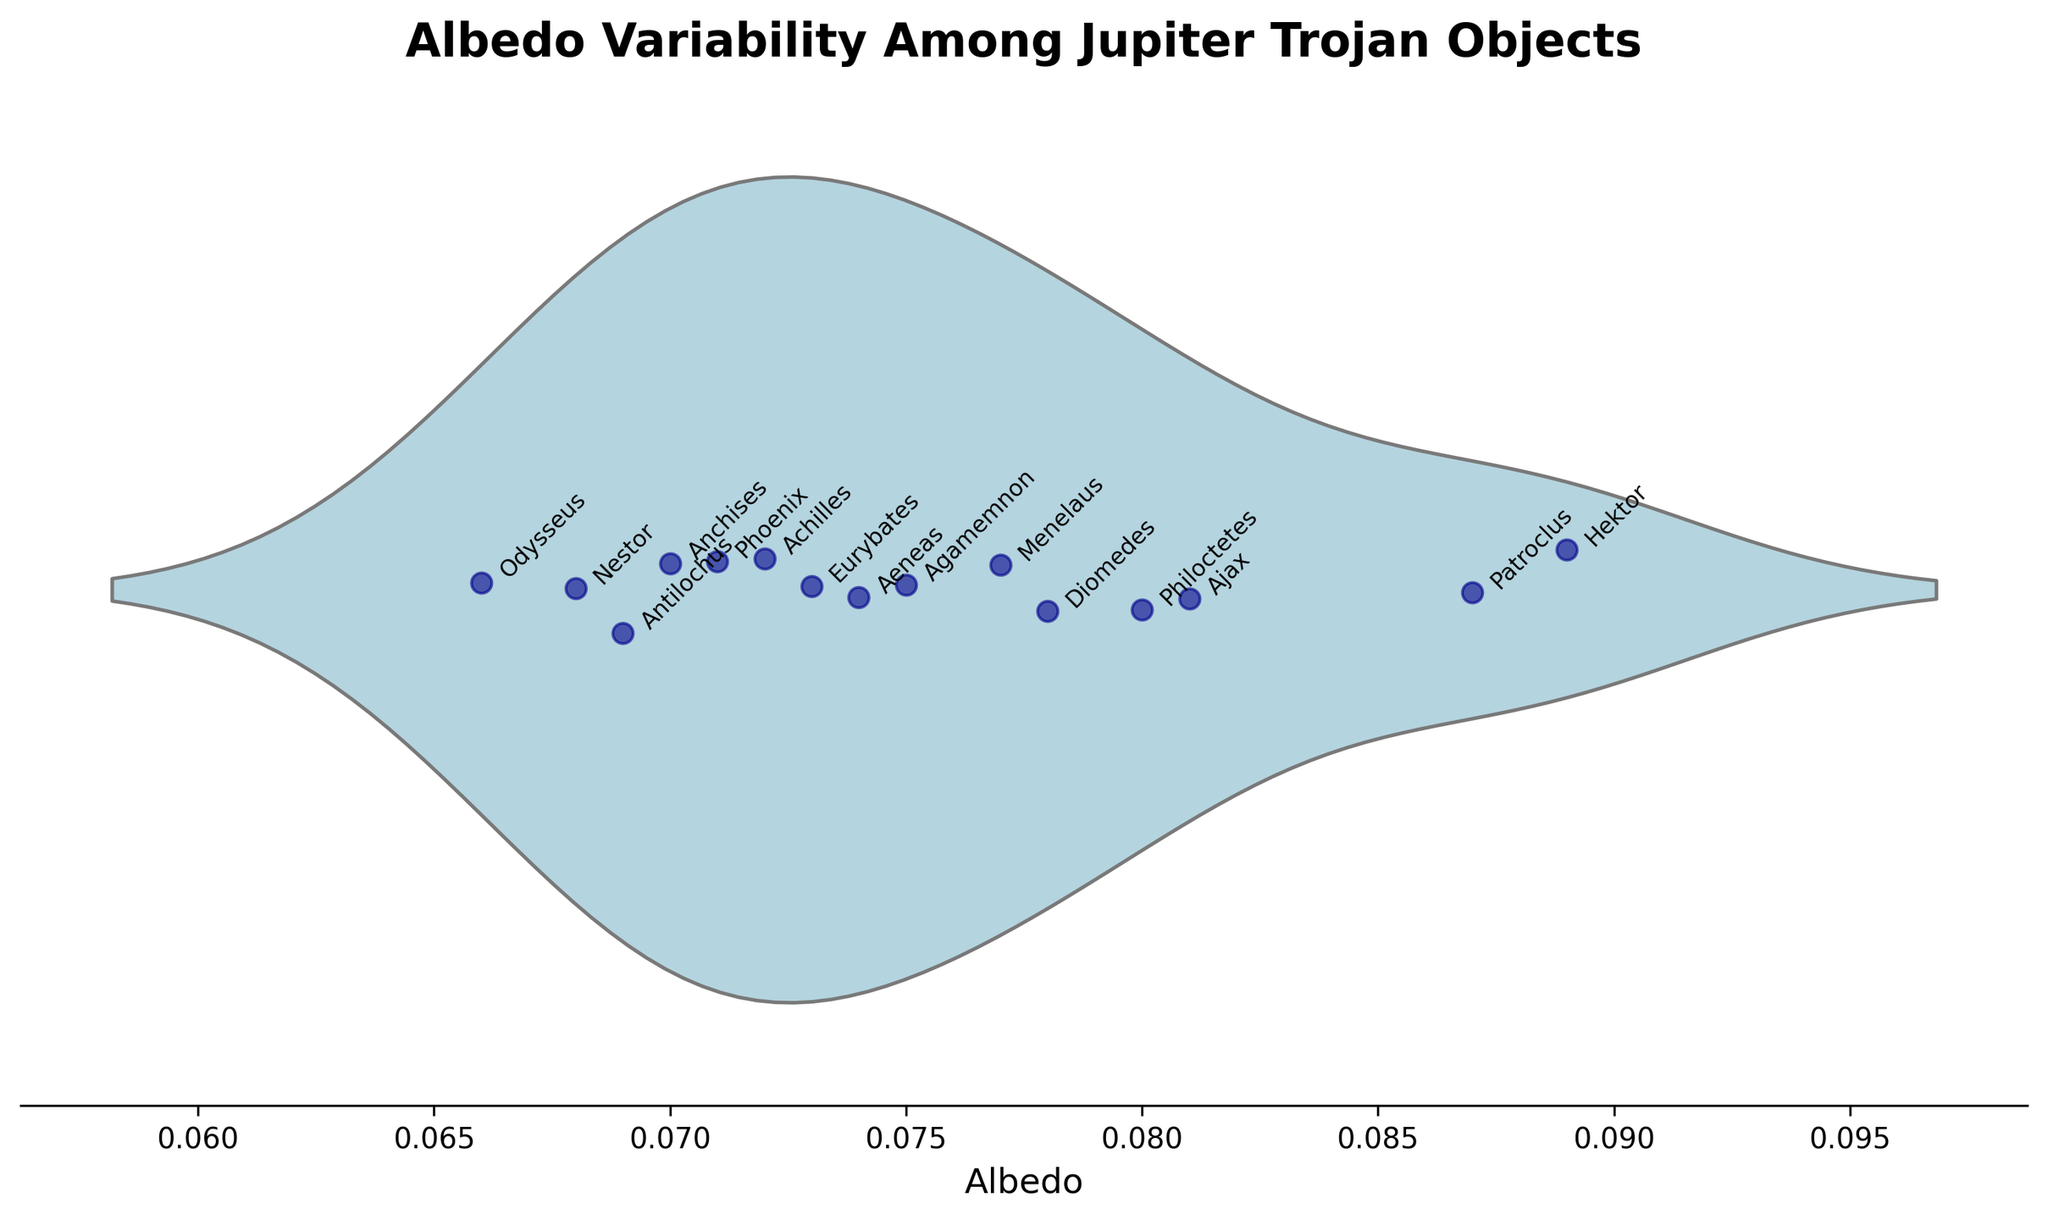What is the title of the plot? The title is located at the top of the plot in bold and large font, making it easily readable.
Answer: Albedo Variability Among Jupiter Trojan Objects Which object has the highest albedo value? Look for the point located farthest to the right on the x-axis; it corresponds to the highest albedo value.
Answer: Hektor How many Jupiter Trojan objects are displayed in the plot? Count the number of data points or jitters representing each object. Each point corresponds to a unique object.
Answer: 15 What is the range of albedo values present among the Jupiter Trojans in the plot? Identify the minimum and maximum values on the x-axis where the data points are scattered, and calculate the range.
Answer: 0.066 to 0.089 Which object has an albedo closest to 0.075? Check the x-axis for the albedo value of 0.075 and identify the jittered point nearest to this value.
Answer: Agamemnon What is the median albedo value of the Jupiter Trojans in the plot? Identify the middle value of the albedo when the values are ordered from smallest to largest. The median is the value that lies at the center of the distribution in the violin plot.
Answer: 0.073 Compare the albedo values of Ajax and Achilles. Which one has a higher albedo? Locate the points for Ajax and Achilles and compare their positions on the x-axis. The point further to the right has a higher albedo.
Answer: Ajax What is the difference between the highest and lowest albedo values? Subtract the minimum albedo value from the maximum albedo value. This gives the range of albedo values.
Answer: 0.023 Which object names are annotated near the middle of the violin plot? Look at the annotated names around the center region of the violin plot in the x-axis range of approximately 0.073.
Answer: Eurybates, Aeneas, Phoenix Do most of the identified objects have albedo values below or above 0.080? Visually assess the density and distribution of points around the value of 0.080 on the x-axis and determine where most points lie.
Answer: Below 